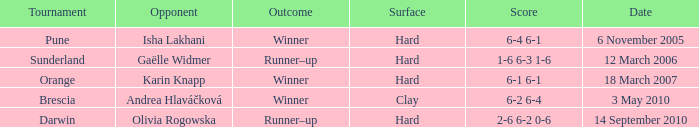What kind of surface was the Tournament at Sunderland played on? Hard. 